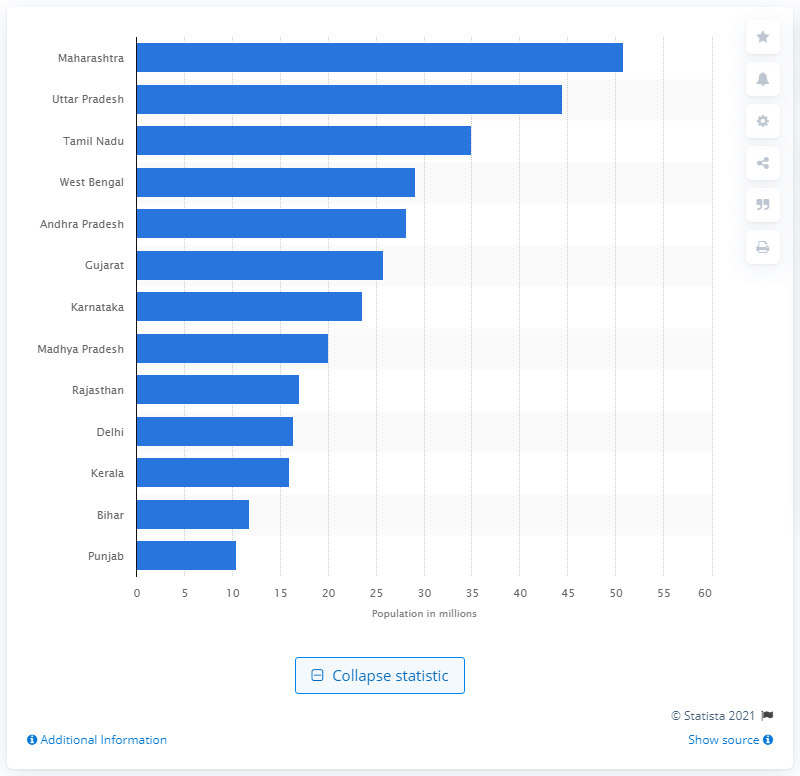Draw attention to some important aspects in this diagram. Maharashtra had the highest population in 2011. 